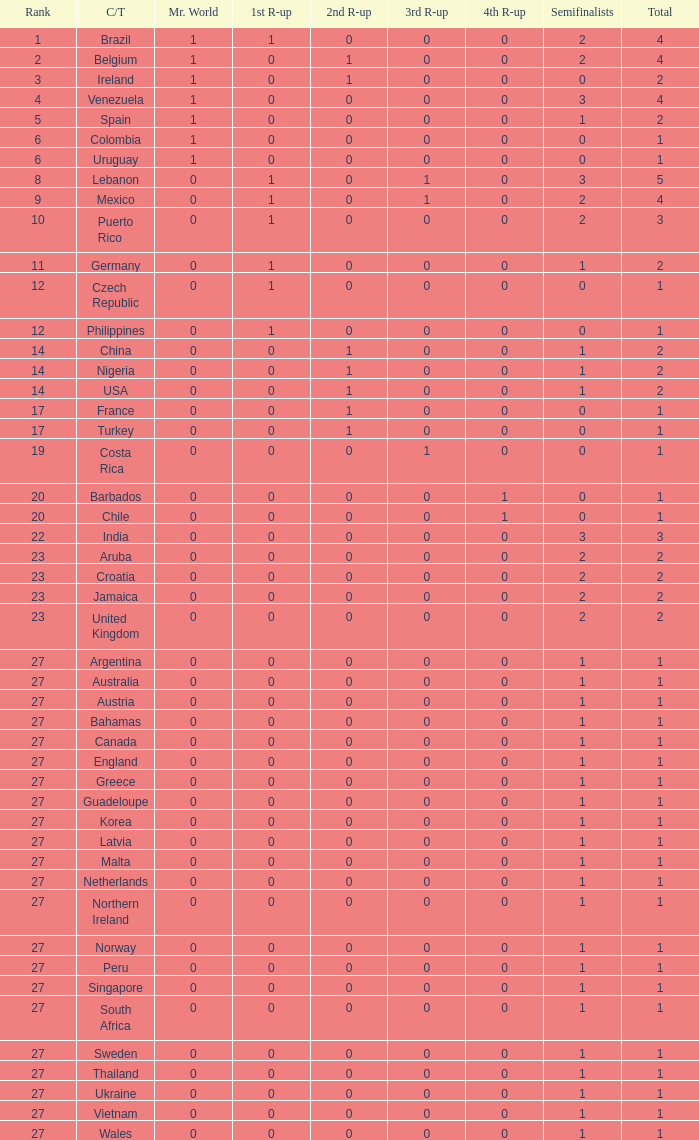What is the smallest 1st runner up value? 0.0. 